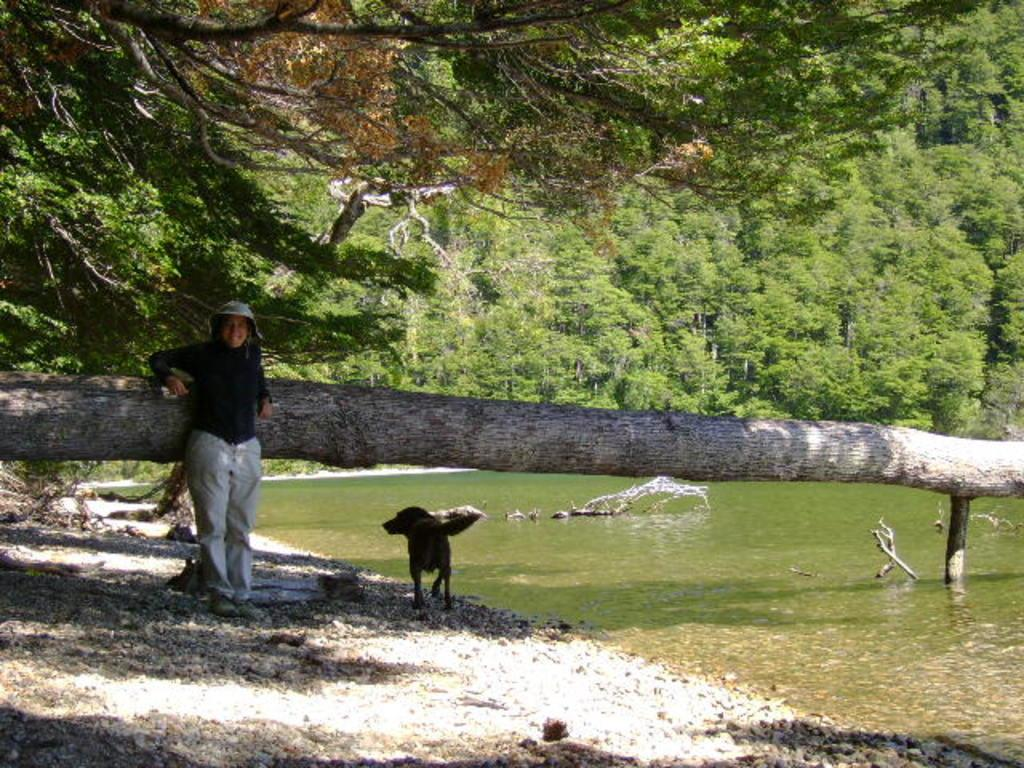What is located in the foreground of the picture? In the foreground of the picture, there are stones, water, the trunk of a tree, a woman, and a dog. What can be seen in the center of the picture? In the center of the picture, there are trees and water. What is the weather like in the image? The weather is sunny. What type of van is parked near the woman in the image? There is no van present in the image; it only features stones, water, the trunk of a tree, a woman, and a dog in the foreground, as well as trees and water in the center. What relation does the woman have with the dog in the image? The image does not provide any information about the relationship between the woman and the dog. 